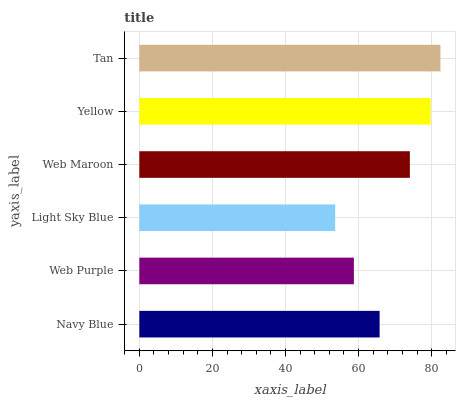Is Light Sky Blue the minimum?
Answer yes or no. Yes. Is Tan the maximum?
Answer yes or no. Yes. Is Web Purple the minimum?
Answer yes or no. No. Is Web Purple the maximum?
Answer yes or no. No. Is Navy Blue greater than Web Purple?
Answer yes or no. Yes. Is Web Purple less than Navy Blue?
Answer yes or no. Yes. Is Web Purple greater than Navy Blue?
Answer yes or no. No. Is Navy Blue less than Web Purple?
Answer yes or no. No. Is Web Maroon the high median?
Answer yes or no. Yes. Is Navy Blue the low median?
Answer yes or no. Yes. Is Light Sky Blue the high median?
Answer yes or no. No. Is Tan the low median?
Answer yes or no. No. 